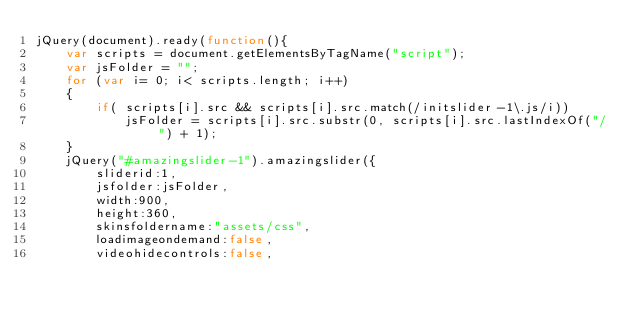<code> <loc_0><loc_0><loc_500><loc_500><_JavaScript_>jQuery(document).ready(function(){
    var scripts = document.getElementsByTagName("script");
    var jsFolder = "";
    for (var i= 0; i< scripts.length; i++)
    {
        if( scripts[i].src && scripts[i].src.match(/initslider-1\.js/i))
            jsFolder = scripts[i].src.substr(0, scripts[i].src.lastIndexOf("/") + 1);
    }
    jQuery("#amazingslider-1").amazingslider({
        sliderid:1,
        jsfolder:jsFolder,
        width:900,
        height:360,
        skinsfoldername:"assets/css",
        loadimageondemand:false,
        videohidecontrols:false,</code> 